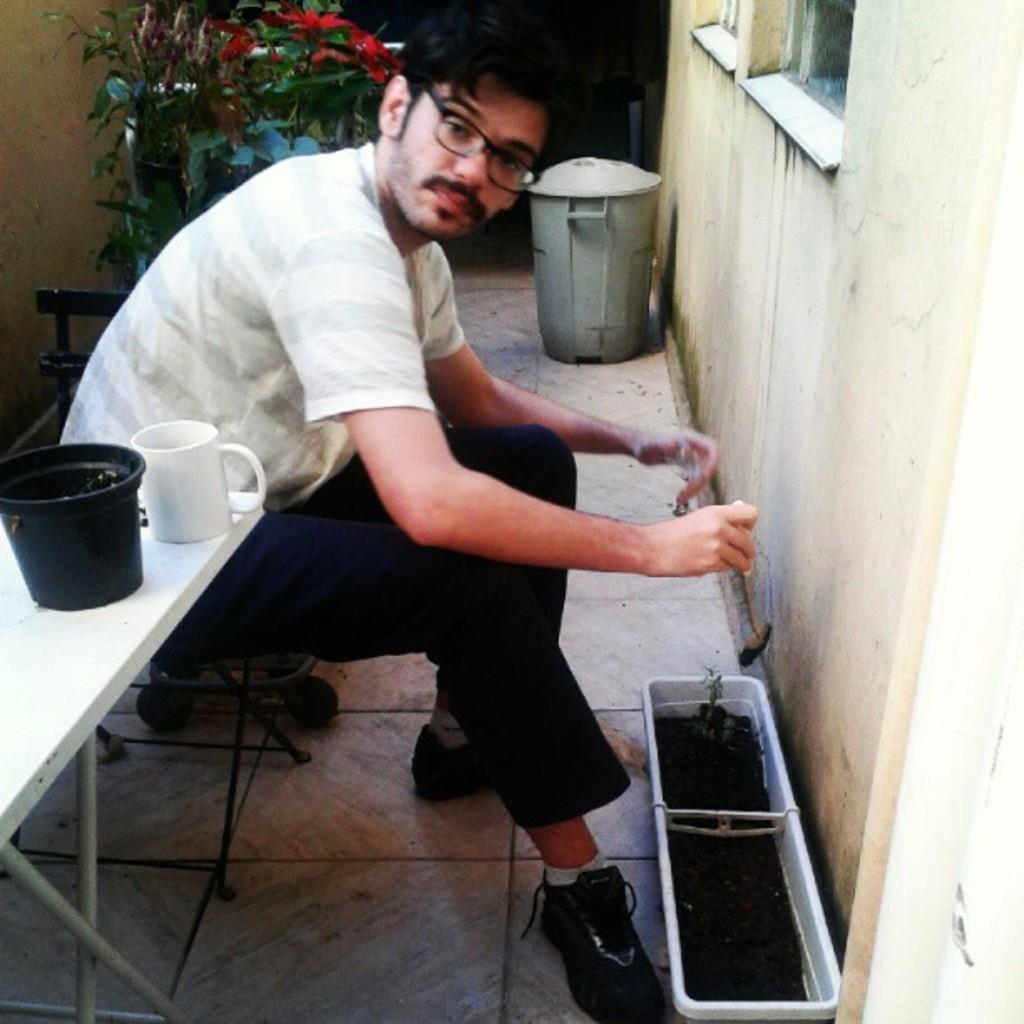Describe this image in one or two sentences. A man is sitting wearing a white t shirt and black pant. He is wearing glasses. He is wearing black shoe. There is a table beside him. On the table there is a black pot and a white mug. There is plant behind him. The plant is having leaves. There is a dustbin. There is window in front of the person. There is a pot inside it there is soil. The man is holding a spatula. This is the floor. 